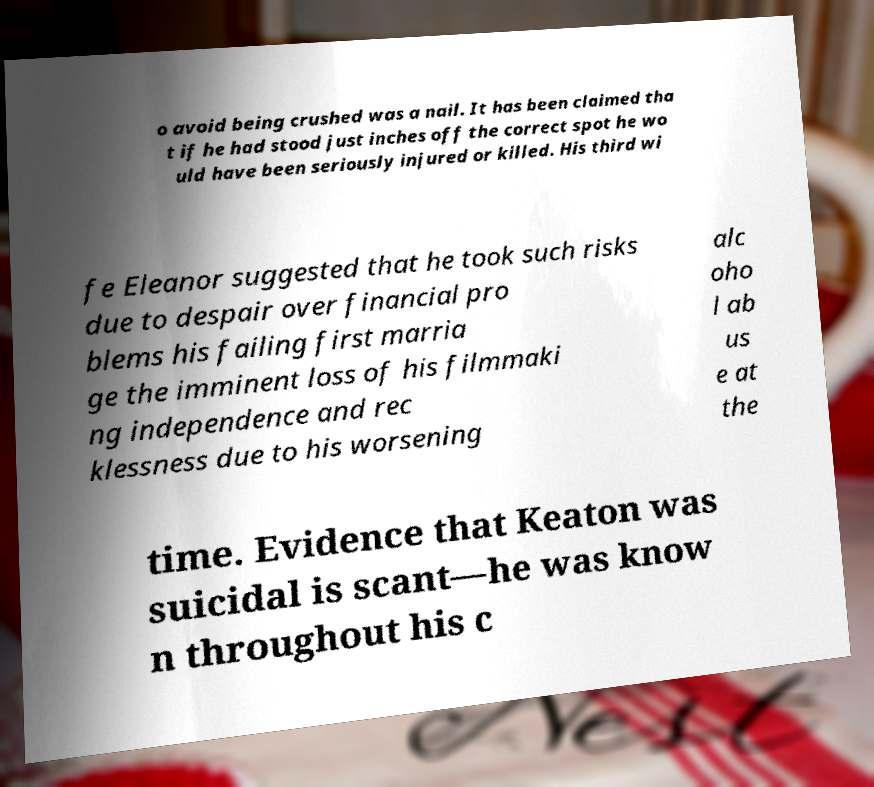I need the written content from this picture converted into text. Can you do that? o avoid being crushed was a nail. It has been claimed tha t if he had stood just inches off the correct spot he wo uld have been seriously injured or killed. His third wi fe Eleanor suggested that he took such risks due to despair over financial pro blems his failing first marria ge the imminent loss of his filmmaki ng independence and rec klessness due to his worsening alc oho l ab us e at the time. Evidence that Keaton was suicidal is scant—he was know n throughout his c 